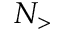Convert formula to latex. <formula><loc_0><loc_0><loc_500><loc_500>N _ { > }</formula> 